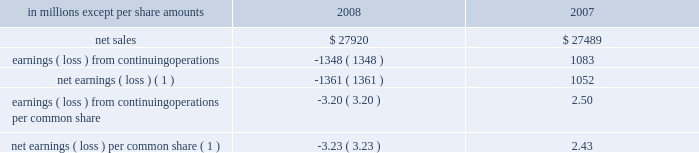The following unaudited pro forma information for the years ended december 31 , 2008 and 2007 pres- ents the results of operations of international paper as if the cbpr and central lewmar acquisitions , and the luiz antonio asset exchange , had occurred on january 1 , 2007 .
This pro forma information does not purport to represent international paper 2019s actual results of operations if the transactions described above would have occurred on january 1 , 2007 , nor is it necessarily indicative of future results .
In millions , except per share amounts 2008 2007 .
Earnings ( loss ) from continuing operations per common share ( 3.20 ) 2.50 net earnings ( loss ) per common share ( 1 ) ( 3.23 ) 2.43 ( 1 ) attributable to international paper company common share- holders .
Joint ventures in october 2007 , international paper and ilim holding s.a .
Announced the completion of the formation of a 50:50 joint venture to operate in russia as ilim group .
To form the joint venture , international paper purchased 50% ( 50 % ) of ilim holding s.a .
( ilim ) for approx- imately $ 620 million , including $ 545 million in cash and $ 75 million of notes payable , and contributed an additional $ 21 million in 2008 .
The company 2019s investment in ilim totaled approximately $ 465 mil- lion at december 31 , 2009 , which is approximately $ 190 million higher than the company 2019s share of the underlying net assets of ilim .
This basis difference primarily consists of the estimated fair value write-up of ilim plant , property and equipment of $ 150 million that is being amortized as a reduction of reported net income over the estimated remaining useful lives of the related assets , goodwill of $ 90 million and other basis differences of $ 50 million , including deferred taxes .
A key element of the proposed joint venture strategy is a long-term investment program in which the joint venture will invest , through cash from operations and additional borrowings by the joint venture , approximately $ 1.5 billion in ilim 2019s three mills over approximately five years .
This planned investment in the russian pulp and paper industry will be used to upgrade equipment , increase production capacity and allow for new high-value uncoated paper , pulp and corrugated packaging product development .
This capital expansion strategy is expected to be ini- tiated in the second half of 2010 , subject to ilim obtaining financing sufficient to fund the project .
Note 7 businesses held for sale , divestitures and impairments discontinued operations 2008 : during the fourth quarter of 2008 , the com- pany recorded pre-tax gains of $ 9 million ( $ 5 million after taxes ) for adjustments to reserves associated with the sale of discontinued operations .
During the first quarter of 2008 , the company recorded a pre-tax charge of $ 25 million ( $ 16 million after taxes ) related to the final settlement of a post- closing adjustment to the purchase price received by the company for the sale of its beverage packaging business , and a $ 3 million charge before taxes ( $ 2 million after taxes ) for 2008 operating losses related to certain wood products facilities .
2007 : during the fourth quarter of 2007 , the com- pany recorded a pre-tax charge of $ 9 million ( $ 6 mil- lion after taxes ) and a pre-tax credit of $ 4 million ( $ 3 million after taxes ) relating to adjustments to esti- mated losses on the sales of its beverage packaging and wood products businesses , respectively .
Addi- tionally , during the fourth quarter , a $ 4 million pre-tax charge ( $ 3 million after taxes ) was recorded for additional taxes associated with the sale of the company 2019s former weldwood of canada limited business .
During the third quarter of 2007 , the company com- pleted the sale of the remainder of its non-u.s .
Beverage packaging business .
During the second quarter of 2007 , the company recorded pre-tax charges of $ 6 million ( $ 4 million after taxes ) and $ 5 million ( $ 3 million after taxes ) relating to adjustments to estimated losses on the sales of its wood products and beverage packaging businesses , respectively .
During the first quarter of 2007 , the company recorded pre-tax credits of $ 21 million ( $ 9 million after taxes ) and $ 6 million ( $ 4 million after taxes ) relating to the sales of its wood products and kraft papers businesses , respectively .
In addition , a $ 15 million pre-tax charge ( $ 39 million after taxes ) was recorded for adjustments to the loss on the com- pletion of the sale of most of the beverage packaging business .
Finally , a pre-tax credit of approximately $ 10 million ( $ 6 million after taxes ) was recorded for refunds received from the canadian government of .
What was the change in pro forma net earnings ( loss ) per common share between 2007 and 2008? 
Computations: (-3.23 - 2.43)
Answer: -5.66. The following unaudited pro forma information for the years ended december 31 , 2008 and 2007 pres- ents the results of operations of international paper as if the cbpr and central lewmar acquisitions , and the luiz antonio asset exchange , had occurred on january 1 , 2007 .
This pro forma information does not purport to represent international paper 2019s actual results of operations if the transactions described above would have occurred on january 1 , 2007 , nor is it necessarily indicative of future results .
In millions , except per share amounts 2008 2007 .
Earnings ( loss ) from continuing operations per common share ( 3.20 ) 2.50 net earnings ( loss ) per common share ( 1 ) ( 3.23 ) 2.43 ( 1 ) attributable to international paper company common share- holders .
Joint ventures in october 2007 , international paper and ilim holding s.a .
Announced the completion of the formation of a 50:50 joint venture to operate in russia as ilim group .
To form the joint venture , international paper purchased 50% ( 50 % ) of ilim holding s.a .
( ilim ) for approx- imately $ 620 million , including $ 545 million in cash and $ 75 million of notes payable , and contributed an additional $ 21 million in 2008 .
The company 2019s investment in ilim totaled approximately $ 465 mil- lion at december 31 , 2009 , which is approximately $ 190 million higher than the company 2019s share of the underlying net assets of ilim .
This basis difference primarily consists of the estimated fair value write-up of ilim plant , property and equipment of $ 150 million that is being amortized as a reduction of reported net income over the estimated remaining useful lives of the related assets , goodwill of $ 90 million and other basis differences of $ 50 million , including deferred taxes .
A key element of the proposed joint venture strategy is a long-term investment program in which the joint venture will invest , through cash from operations and additional borrowings by the joint venture , approximately $ 1.5 billion in ilim 2019s three mills over approximately five years .
This planned investment in the russian pulp and paper industry will be used to upgrade equipment , increase production capacity and allow for new high-value uncoated paper , pulp and corrugated packaging product development .
This capital expansion strategy is expected to be ini- tiated in the second half of 2010 , subject to ilim obtaining financing sufficient to fund the project .
Note 7 businesses held for sale , divestitures and impairments discontinued operations 2008 : during the fourth quarter of 2008 , the com- pany recorded pre-tax gains of $ 9 million ( $ 5 million after taxes ) for adjustments to reserves associated with the sale of discontinued operations .
During the first quarter of 2008 , the company recorded a pre-tax charge of $ 25 million ( $ 16 million after taxes ) related to the final settlement of a post- closing adjustment to the purchase price received by the company for the sale of its beverage packaging business , and a $ 3 million charge before taxes ( $ 2 million after taxes ) for 2008 operating losses related to certain wood products facilities .
2007 : during the fourth quarter of 2007 , the com- pany recorded a pre-tax charge of $ 9 million ( $ 6 mil- lion after taxes ) and a pre-tax credit of $ 4 million ( $ 3 million after taxes ) relating to adjustments to esti- mated losses on the sales of its beverage packaging and wood products businesses , respectively .
Addi- tionally , during the fourth quarter , a $ 4 million pre-tax charge ( $ 3 million after taxes ) was recorded for additional taxes associated with the sale of the company 2019s former weldwood of canada limited business .
During the third quarter of 2007 , the company com- pleted the sale of the remainder of its non-u.s .
Beverage packaging business .
During the second quarter of 2007 , the company recorded pre-tax charges of $ 6 million ( $ 4 million after taxes ) and $ 5 million ( $ 3 million after taxes ) relating to adjustments to estimated losses on the sales of its wood products and beverage packaging businesses , respectively .
During the first quarter of 2007 , the company recorded pre-tax credits of $ 21 million ( $ 9 million after taxes ) and $ 6 million ( $ 4 million after taxes ) relating to the sales of its wood products and kraft papers businesses , respectively .
In addition , a $ 15 million pre-tax charge ( $ 39 million after taxes ) was recorded for adjustments to the loss on the com- pletion of the sale of most of the beverage packaging business .
Finally , a pre-tax credit of approximately $ 10 million ( $ 6 million after taxes ) was recorded for refunds received from the canadian government of .
What was the change in the net sales from 2007 to 2008? 
Computations: (27920 - 27489)
Answer: 431.0. 